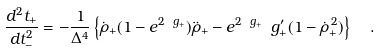Convert formula to latex. <formula><loc_0><loc_0><loc_500><loc_500>\frac { d ^ { 2 } t _ { + } } { d t _ { - } ^ { 2 } } = - \frac { 1 } { \Delta ^ { 4 } } \left \{ \dot { \rho } _ { + } ( 1 - e ^ { 2 \ g _ { + } } ) \ddot { \rho } _ { + } - e ^ { 2 \ g _ { + } } \ g _ { + } ^ { \prime } ( 1 - \dot { \rho } _ { + } ^ { \, 2 } ) \right \} \ \ .</formula> 